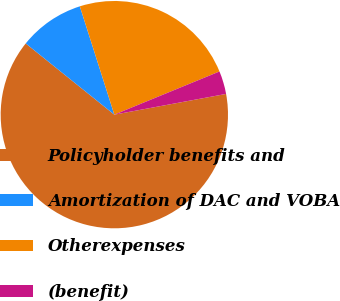Convert chart to OTSL. <chart><loc_0><loc_0><loc_500><loc_500><pie_chart><fcel>Policyholder benefits and<fcel>Amortization of DAC and VOBA<fcel>Otherexpenses<fcel>(benefit)<nl><fcel>63.69%<fcel>9.32%<fcel>23.71%<fcel>3.28%<nl></chart> 